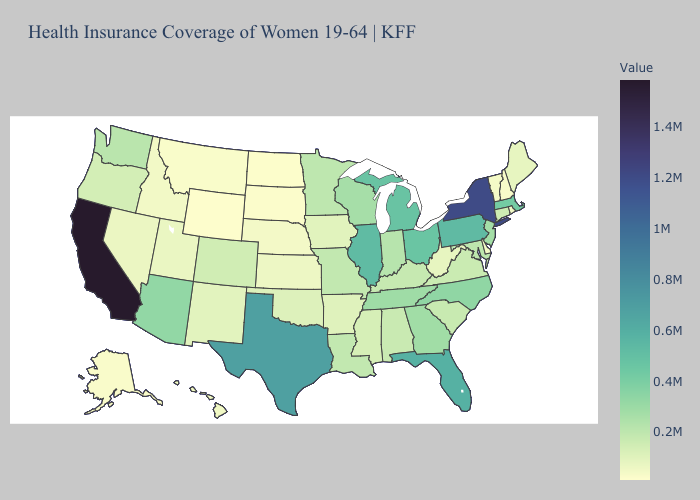Which states have the highest value in the USA?
Give a very brief answer. California. Does West Virginia have the lowest value in the USA?
Short answer required. No. Among the states that border Iowa , which have the highest value?
Keep it brief. Illinois. Among the states that border Nevada , does California have the highest value?
Quick response, please. Yes. Does Connecticut have the lowest value in the USA?
Write a very short answer. No. Which states have the lowest value in the MidWest?
Give a very brief answer. North Dakota. Which states hav the highest value in the West?
Quick response, please. California. 